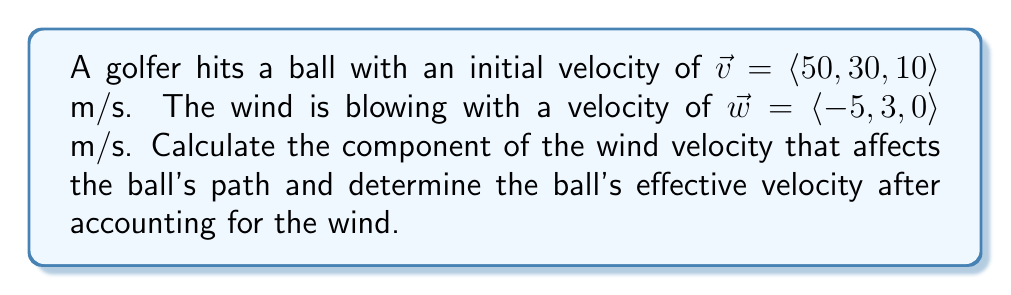Help me with this question. 1. To find the component of the wind velocity that affects the ball's path, we need to project the wind vector onto the ball's velocity vector:

   $$\text{proj}_{\vec{v}}\vec{w} = \frac{\vec{v} \cdot \vec{w}}{\|\vec{v}\|^2} \vec{v}$$

2. Calculate the dot product $\vec{v} \cdot \vec{w}$:
   $$\vec{v} \cdot \vec{w} = 50(-5) + 30(3) + 10(0) = -250 + 90 + 0 = -160$$

3. Calculate the magnitude of $\vec{v}$ squared:
   $$\|\vec{v}\|^2 = 50^2 + 30^2 + 10^2 = 2500 + 900 + 100 = 3500$$

4. Substitute into the projection formula:
   $$\text{proj}_{\vec{v}}\vec{w} = \frac{-160}{3500} \langle 50, 30, 10 \rangle = \langle -2.29, -1.37, -0.46 \rangle$$

5. The effective velocity of the ball is the sum of its initial velocity and the wind's effect:
   $$\vec{v}_{\text{eff}} = \vec{v} + \text{proj}_{\vec{v}}\vec{w}$$
   $$\vec{v}_{\text{eff}} = \langle 50, 30, 10 \rangle + \langle -2.29, -1.37, -0.46 \rangle$$
   $$\vec{v}_{\text{eff}} = \langle 47.71, 28.63, 9.54 \rangle$$
Answer: $\vec{v}_{\text{eff}} = \langle 47.71, 28.63, 9.54 \rangle$ m/s 